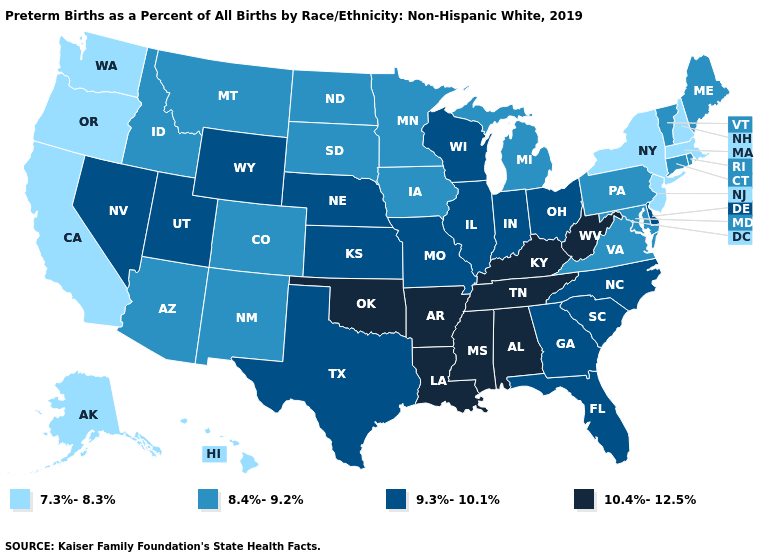Among the states that border Arizona , does California have the lowest value?
Answer briefly. Yes. Name the states that have a value in the range 10.4%-12.5%?
Give a very brief answer. Alabama, Arkansas, Kentucky, Louisiana, Mississippi, Oklahoma, Tennessee, West Virginia. What is the highest value in the USA?
Write a very short answer. 10.4%-12.5%. How many symbols are there in the legend?
Keep it brief. 4. What is the lowest value in states that border Connecticut?
Keep it brief. 7.3%-8.3%. Which states have the lowest value in the USA?
Be succinct. Alaska, California, Hawaii, Massachusetts, New Hampshire, New Jersey, New York, Oregon, Washington. What is the highest value in the USA?
Write a very short answer. 10.4%-12.5%. What is the value of New Jersey?
Be succinct. 7.3%-8.3%. What is the value of Kentucky?
Quick response, please. 10.4%-12.5%. What is the value of Idaho?
Give a very brief answer. 8.4%-9.2%. Does the map have missing data?
Keep it brief. No. Among the states that border Rhode Island , does Connecticut have the highest value?
Quick response, please. Yes. What is the value of Ohio?
Quick response, please. 9.3%-10.1%. What is the highest value in the USA?
Quick response, please. 10.4%-12.5%. Does Texas have the highest value in the USA?
Quick response, please. No. 